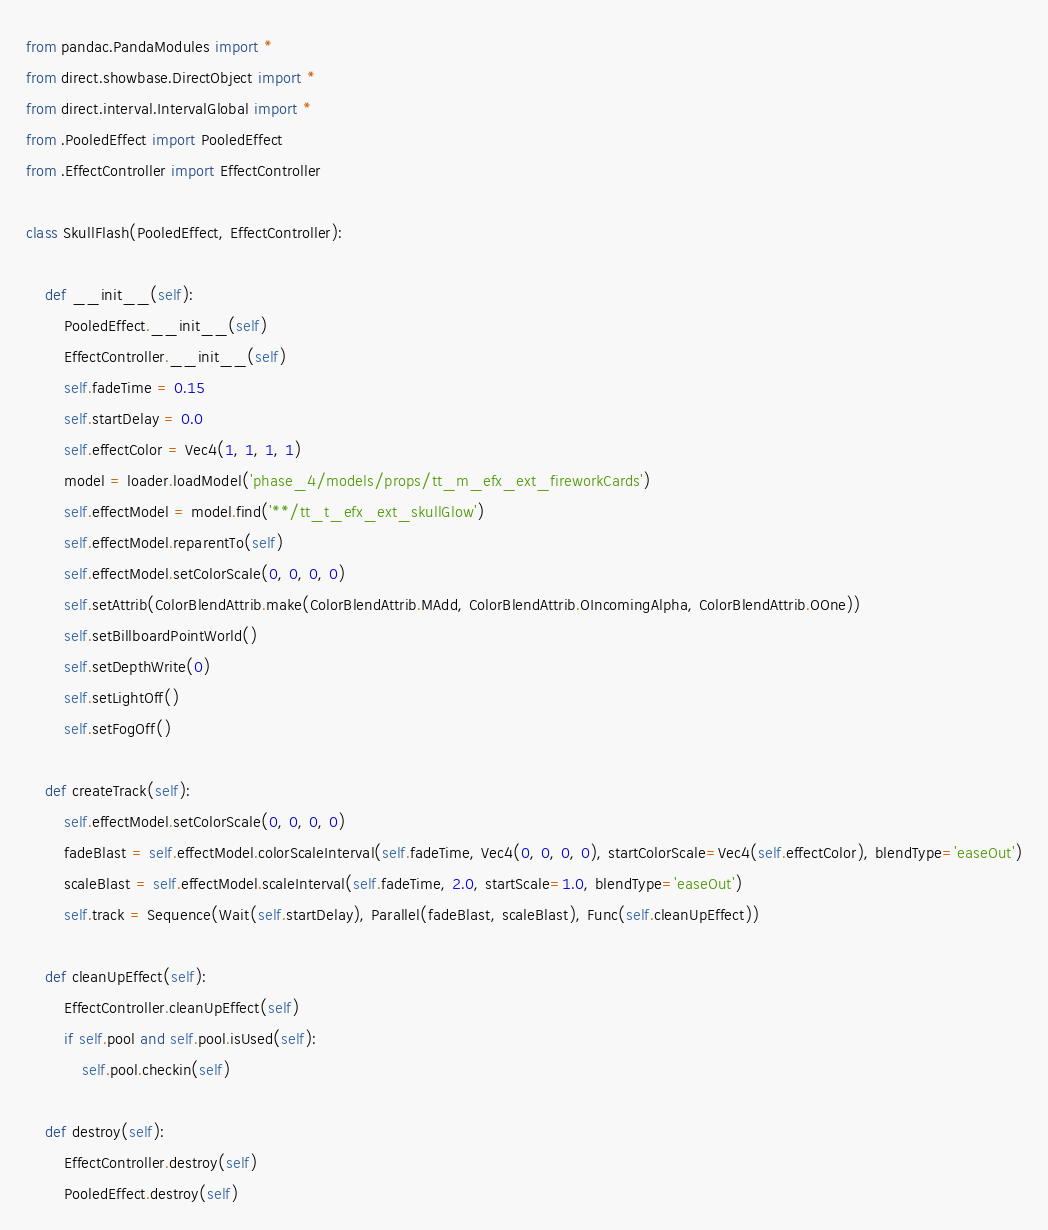Convert code to text. <code><loc_0><loc_0><loc_500><loc_500><_Python_>from pandac.PandaModules import *
from direct.showbase.DirectObject import *
from direct.interval.IntervalGlobal import *
from .PooledEffect import PooledEffect
from .EffectController import EffectController

class SkullFlash(PooledEffect, EffectController):

    def __init__(self):
        PooledEffect.__init__(self)
        EffectController.__init__(self)
        self.fadeTime = 0.15
        self.startDelay = 0.0
        self.effectColor = Vec4(1, 1, 1, 1)
        model = loader.loadModel('phase_4/models/props/tt_m_efx_ext_fireworkCards')
        self.effectModel = model.find('**/tt_t_efx_ext_skullGlow')
        self.effectModel.reparentTo(self)
        self.effectModel.setColorScale(0, 0, 0, 0)
        self.setAttrib(ColorBlendAttrib.make(ColorBlendAttrib.MAdd, ColorBlendAttrib.OIncomingAlpha, ColorBlendAttrib.OOne))
        self.setBillboardPointWorld()
        self.setDepthWrite(0)
        self.setLightOff()
        self.setFogOff()

    def createTrack(self):
        self.effectModel.setColorScale(0, 0, 0, 0)
        fadeBlast = self.effectModel.colorScaleInterval(self.fadeTime, Vec4(0, 0, 0, 0), startColorScale=Vec4(self.effectColor), blendType='easeOut')
        scaleBlast = self.effectModel.scaleInterval(self.fadeTime, 2.0, startScale=1.0, blendType='easeOut')
        self.track = Sequence(Wait(self.startDelay), Parallel(fadeBlast, scaleBlast), Func(self.cleanUpEffect))

    def cleanUpEffect(self):
        EffectController.cleanUpEffect(self)
        if self.pool and self.pool.isUsed(self):
            self.pool.checkin(self)

    def destroy(self):
        EffectController.destroy(self)
        PooledEffect.destroy(self)
</code> 